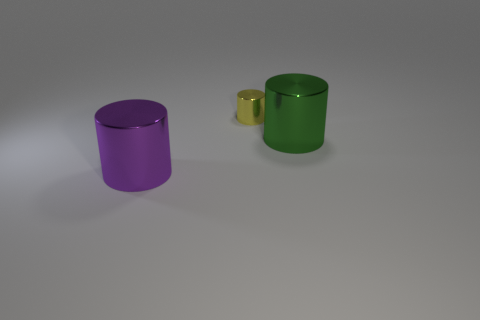Is there any other thing that has the same shape as the purple shiny thing?
Offer a very short reply. Yes. Is there another thing of the same color as the small metallic object?
Your response must be concise. No. Is the big cylinder that is on the right side of the large purple shiny thing made of the same material as the tiny thing that is behind the purple shiny object?
Give a very brief answer. Yes. What is the color of the small metallic cylinder?
Your answer should be compact. Yellow. There is a cylinder in front of the big metal cylinder that is behind the purple shiny thing in front of the large green cylinder; what is its size?
Make the answer very short. Large. How many other objects are there of the same size as the purple metal thing?
Offer a very short reply. 1. What number of yellow cylinders have the same material as the purple cylinder?
Give a very brief answer. 1. What shape is the large metal thing behind the big purple metal object?
Offer a terse response. Cylinder. Do the small yellow cylinder and the cylinder that is on the left side of the tiny metallic object have the same material?
Your answer should be very brief. Yes. Is there a small cylinder?
Your answer should be very brief. Yes. 